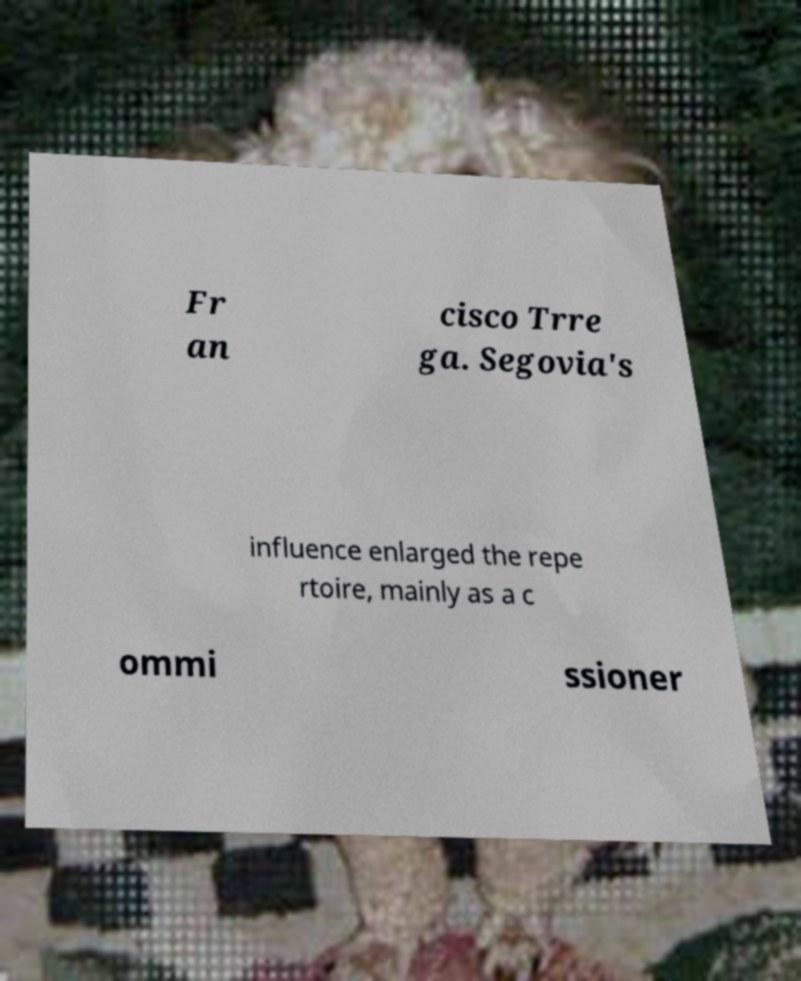Could you extract and type out the text from this image? Fr an cisco Trre ga. Segovia's influence enlarged the repe rtoire, mainly as a c ommi ssioner 